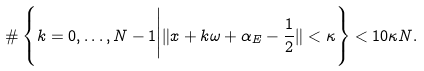Convert formula to latex. <formula><loc_0><loc_0><loc_500><loc_500>\# \left \{ k = 0 , \dots , N - 1 \Big | \| x + k \omega + \alpha _ { E } - \frac { 1 } { 2 } \| < \kappa \right \} < 1 0 \kappa N .</formula> 